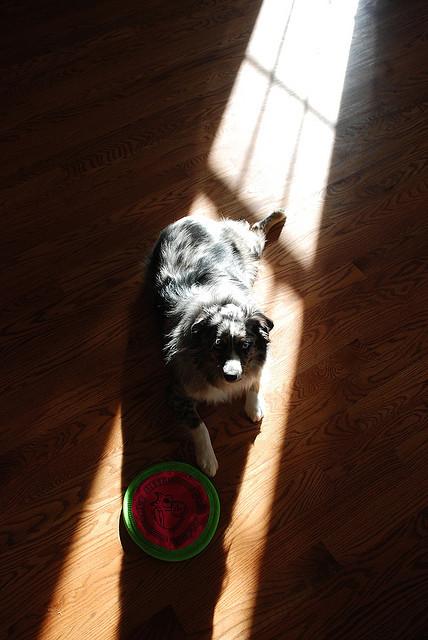What is causing the shadow?
Keep it brief. Sunlight. Is the dog lying down?
Keep it brief. Yes. What animal is in this photo?
Answer briefly. Dog. 